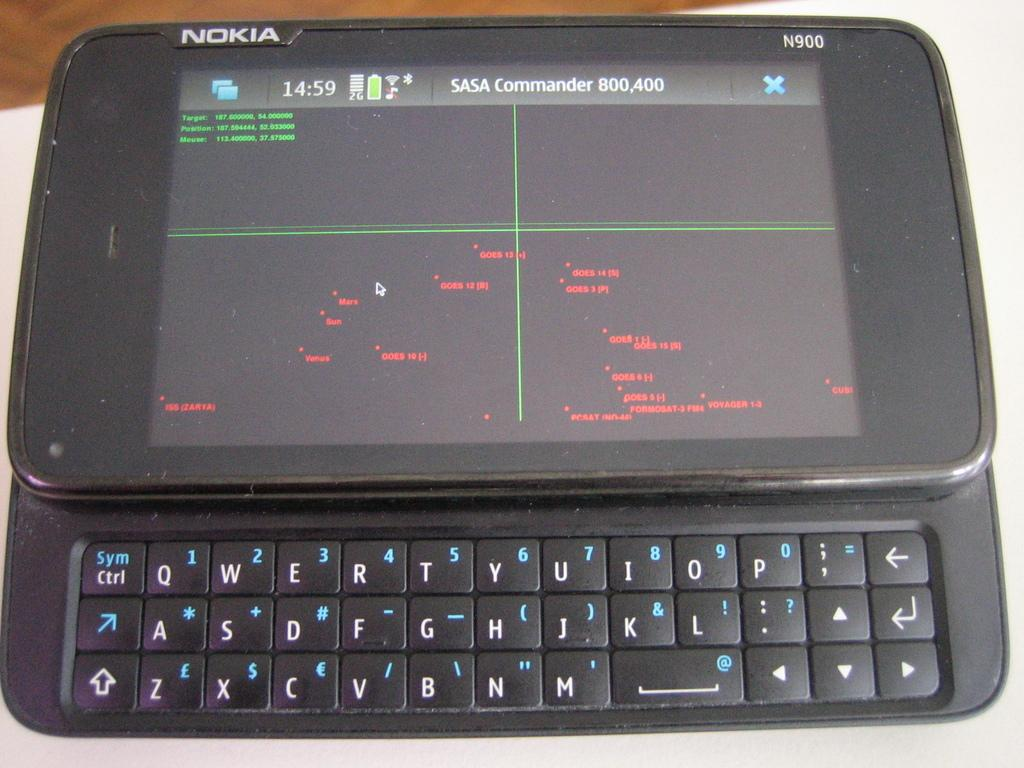<image>
Create a compact narrative representing the image presented. The SASA Commander screen is shown on a Nokia device. 